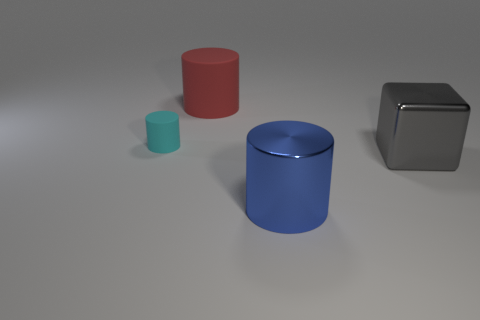There is a red rubber thing on the left side of the big cylinder on the right side of the large matte thing; what shape is it?
Provide a short and direct response. Cylinder. How many big things are cubes or red cylinders?
Your answer should be very brief. 2. What number of small green metallic things are the same shape as the blue shiny object?
Keep it short and to the point. 0. Is the shape of the cyan rubber object the same as the large red object that is behind the metallic cylinder?
Offer a terse response. Yes. What number of gray things are on the left side of the small rubber cylinder?
Keep it short and to the point. 0. Are there any rubber things that have the same size as the red cylinder?
Your response must be concise. No. Do the large thing left of the shiny cylinder and the large blue shiny object have the same shape?
Offer a very short reply. Yes. The cube has what color?
Offer a terse response. Gray. Are any big things visible?
Offer a very short reply. Yes. There is a cylinder that is made of the same material as the large gray thing; what size is it?
Provide a short and direct response. Large. 